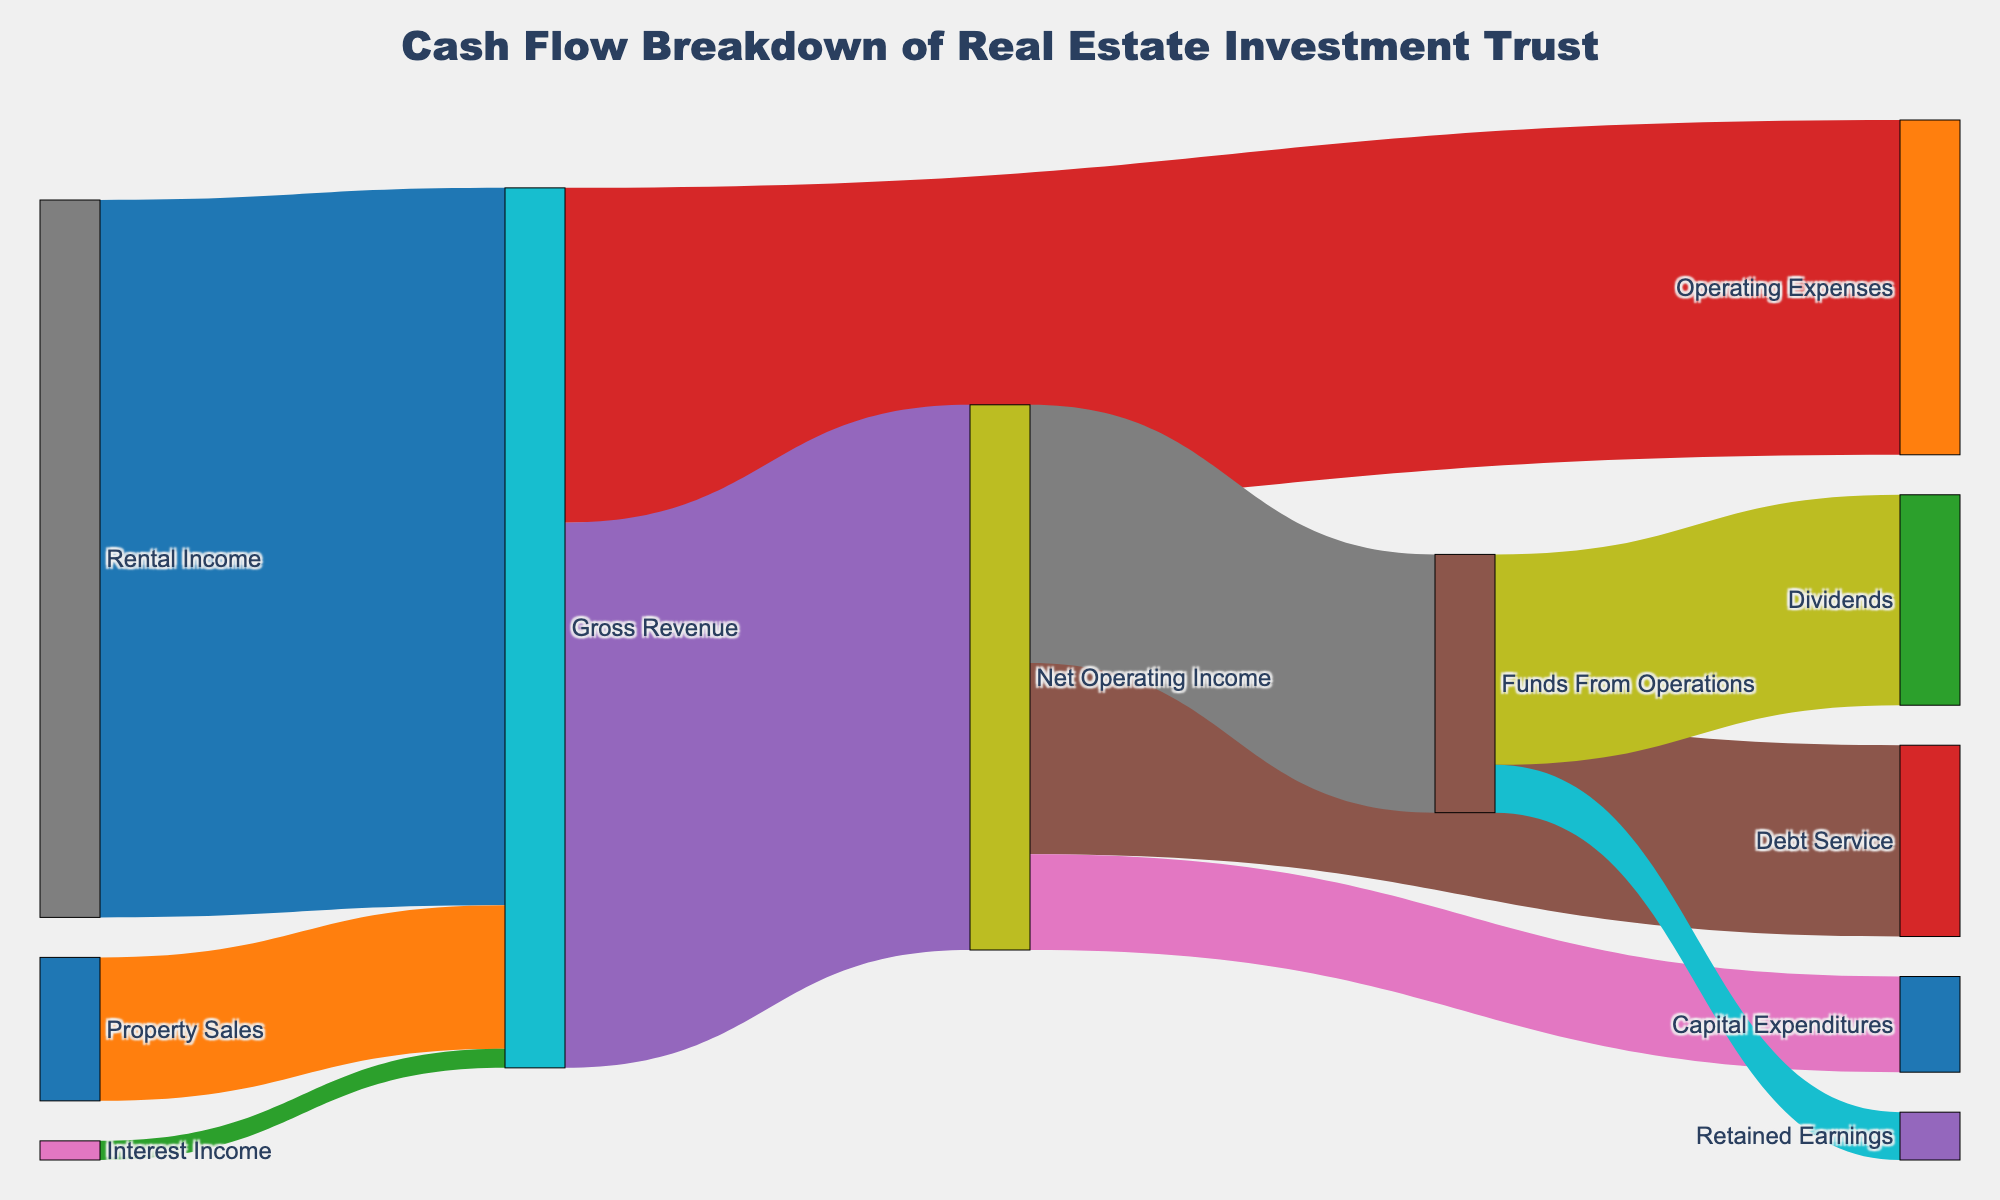What is the title of the figure? The title is located at the top of the figure. It provides a brief summary of the content being visualized. In this case, the title is "Cash Flow Breakdown of Real Estate Investment Trust".
Answer: Cash Flow Breakdown of Real Estate Investment Trust What is the largest revenue component flowing into Gross Revenue? By visually inspecting the flow sizes in the figure, it can be observed that Rental Income has the largest flow compared to other components flowing into Gross Revenue.
Answer: Rental Income What are the two main components flowing out of Net Operating Income? Observing the links in the figure originating from Net Operating Income, we can see that the two main components are Debt Service and Capital Expenditures.
Answer: Debt Service and Capital Expenditures How much is retained as Retained Earnings from Funds From Operations? By following the flows out of Funds From Operations, we see one of the components is Retained Earnings, which has a value of 5,000,000.
Answer: 5,000,000 What is the total value flowing into Gross Revenue? The total value flowing into Gross Revenue is the sum of all values originating from the sources connecting to it. These include Rental Income (75,000,000), Property Sales (15,000,000), and Interest Income (2,000,000). The total is 75,000,000 + 15,000,000 + 2,000,000 = 92,000,000.
Answer: 92,000,000 How does the value of Dividends compare to the value of Debt Service? By comparing the values from the figure, we see that the value for Dividends is 22,000,000 and for Debt Service is 20,000,000. Therefore, Dividends is greater than Debt Service.
Answer: Dividends is greater than Debt Service What is the difference between Gross Revenue and Operating Expenses? We find the values of Gross Revenue (92,000,000) and Operating Expenses (35,000,000). The difference is calculated as 92,000,000 - 35,000,000 = 57,000,000.
Answer: 57,000,000 Which component receives the largest amount from Net Operating Income? By inspecting the figure, it is clear that Funds From Operations receives the largest amount from Net Operating Income with a value of 27,000,000.
Answer: Funds From Operations What is the sum of Dividends and Retained Earnings? To find this, we sum the values of Dividends (22,000,000) and Retained Earnings (5,000,000). The total is 22,000,000 + 5,000,000 = 27,000,000.
Answer: 27,000,000 Which stream has more value, Capital Expenditures or Operating Expenses? The values from the figure indicate that Capital Expenditures is 10,000,000 while Operating Expenses is 35,000,000. Thus, Operating Expenses has more value.
Answer: Operating Expenses 